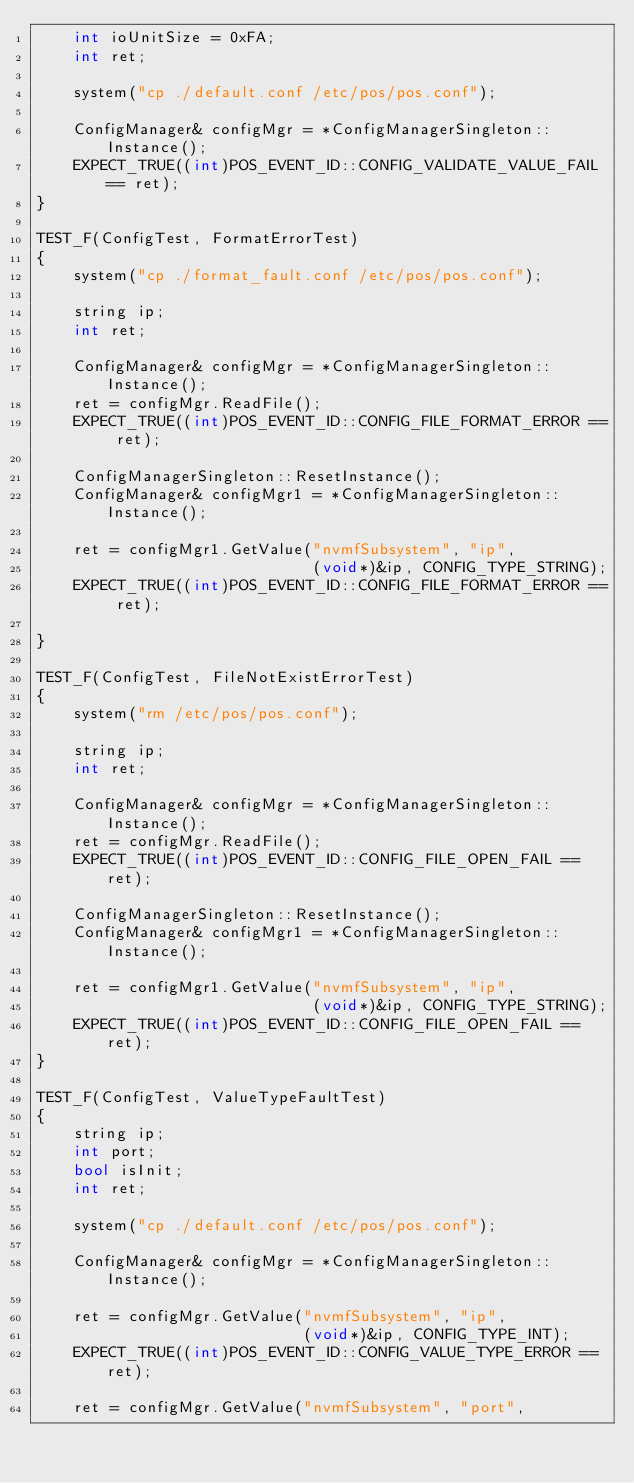<code> <loc_0><loc_0><loc_500><loc_500><_C++_>    int ioUnitSize = 0xFA;
    int ret;

    system("cp ./default.conf /etc/pos/pos.conf");

    ConfigManager& configMgr = *ConfigManagerSingleton::Instance();
    EXPECT_TRUE((int)POS_EVENT_ID::CONFIG_VALIDATE_VALUE_FAIL == ret);
}

TEST_F(ConfigTest, FormatErrorTest)
{
    system("cp ./format_fault.conf /etc/pos/pos.conf");
    
    string ip;
    int ret;
    
    ConfigManager& configMgr = *ConfigManagerSingleton::Instance();
    ret = configMgr.ReadFile();
    EXPECT_TRUE((int)POS_EVENT_ID::CONFIG_FILE_FORMAT_ERROR == ret);

    ConfigManagerSingleton::ResetInstance();
    ConfigManager& configMgr1 = *ConfigManagerSingleton::Instance();
    
    ret = configMgr1.GetValue("nvmfSubsystem", "ip", 
                              (void*)&ip, CONFIG_TYPE_STRING);
    EXPECT_TRUE((int)POS_EVENT_ID::CONFIG_FILE_FORMAT_ERROR == ret);

}

TEST_F(ConfigTest, FileNotExistErrorTest)
{
    system("rm /etc/pos/pos.conf");
    
    string ip;
    int ret;
    
    ConfigManager& configMgr = *ConfigManagerSingleton::Instance();
    ret = configMgr.ReadFile();
    EXPECT_TRUE((int)POS_EVENT_ID::CONFIG_FILE_OPEN_FAIL == ret);

    ConfigManagerSingleton::ResetInstance();
    ConfigManager& configMgr1 = *ConfigManagerSingleton::Instance();
    
    ret = configMgr1.GetValue("nvmfSubsystem", "ip", 
                              (void*)&ip, CONFIG_TYPE_STRING);
    EXPECT_TRUE((int)POS_EVENT_ID::CONFIG_FILE_OPEN_FAIL == ret);
}

TEST_F(ConfigTest, ValueTypeFaultTest)
{
    string ip;
    int port;
    bool isInit;
    int ret;

    system("cp ./default.conf /etc/pos/pos.conf");

    ConfigManager& configMgr = *ConfigManagerSingleton::Instance();
    
    ret = configMgr.GetValue("nvmfSubsystem", "ip", 
                             (void*)&ip, CONFIG_TYPE_INT);
    EXPECT_TRUE((int)POS_EVENT_ID::CONFIG_VALUE_TYPE_ERROR == ret);
    
    ret = configMgr.GetValue("nvmfSubsystem", "port", </code> 